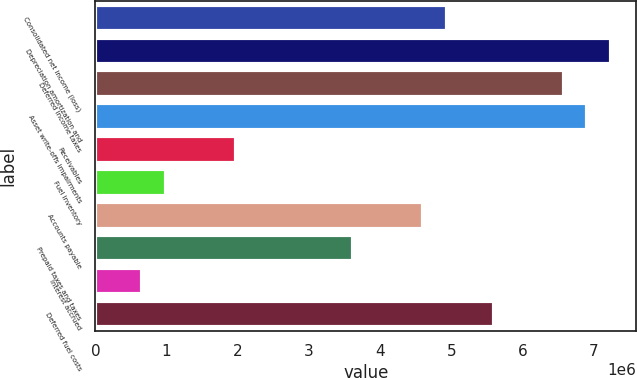<chart> <loc_0><loc_0><loc_500><loc_500><bar_chart><fcel>Consolidated net income (loss)<fcel>Depreciation amortization and<fcel>Deferred income taxes<fcel>Asset write-offs impairments<fcel>Receivables<fcel>Fuel inventory<fcel>Accounts payable<fcel>Prepaid taxes and taxes<fcel>Interest accrued<fcel>Deferred fuel costs<nl><fcel>4.93649e+06<fcel>7.23992e+06<fcel>6.5818e+06<fcel>6.91086e+06<fcel>1.97494e+06<fcel>987755<fcel>4.60743e+06<fcel>3.62025e+06<fcel>658694<fcel>5.59461e+06<nl></chart> 